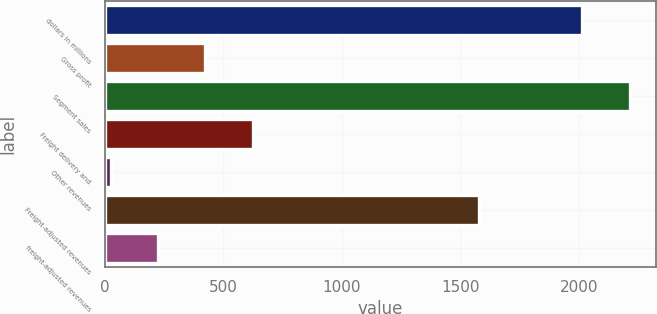Convert chart to OTSL. <chart><loc_0><loc_0><loc_500><loc_500><bar_chart><fcel>dollars in millions<fcel>Gross profit<fcel>Segment sales<fcel>Freight delivery and<fcel>Other revenues<fcel>Freight-adjusted revenues<fcel>freight-adjusted revenues<nl><fcel>2013<fcel>424.28<fcel>2213.09<fcel>624.37<fcel>24.1<fcel>1576<fcel>224.19<nl></chart> 